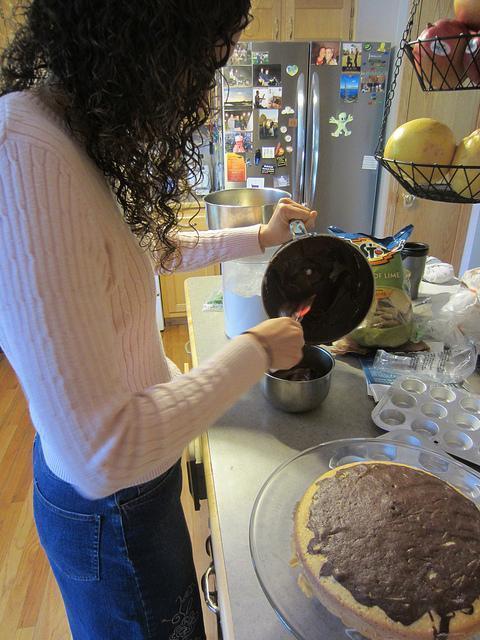How many cakes are there?
Give a very brief answer. 1. 